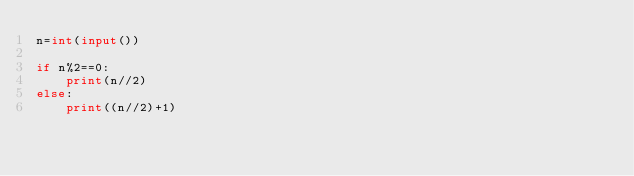<code> <loc_0><loc_0><loc_500><loc_500><_Python_>n=int(input())

if n%2==0:
    print(n//2)
else:
    print((n//2)+1)</code> 